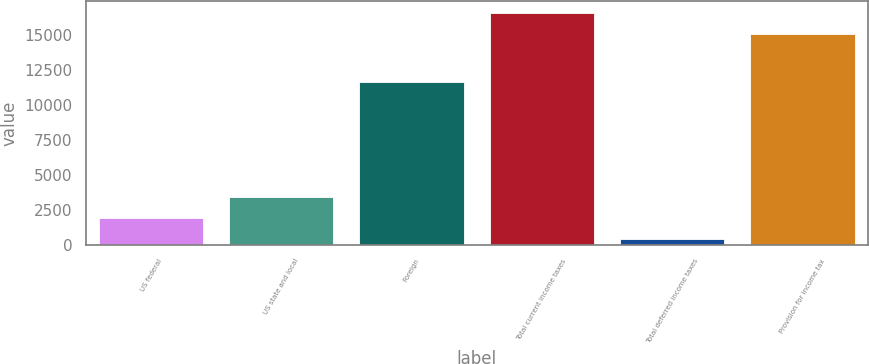Convert chart. <chart><loc_0><loc_0><loc_500><loc_500><bar_chart><fcel>US federal<fcel>US state and local<fcel>Foreign<fcel>Total current income taxes<fcel>Total deferred income taxes<fcel>Provision for income tax<nl><fcel>1895.6<fcel>3400.2<fcel>11616<fcel>16550.6<fcel>391<fcel>15046<nl></chart> 